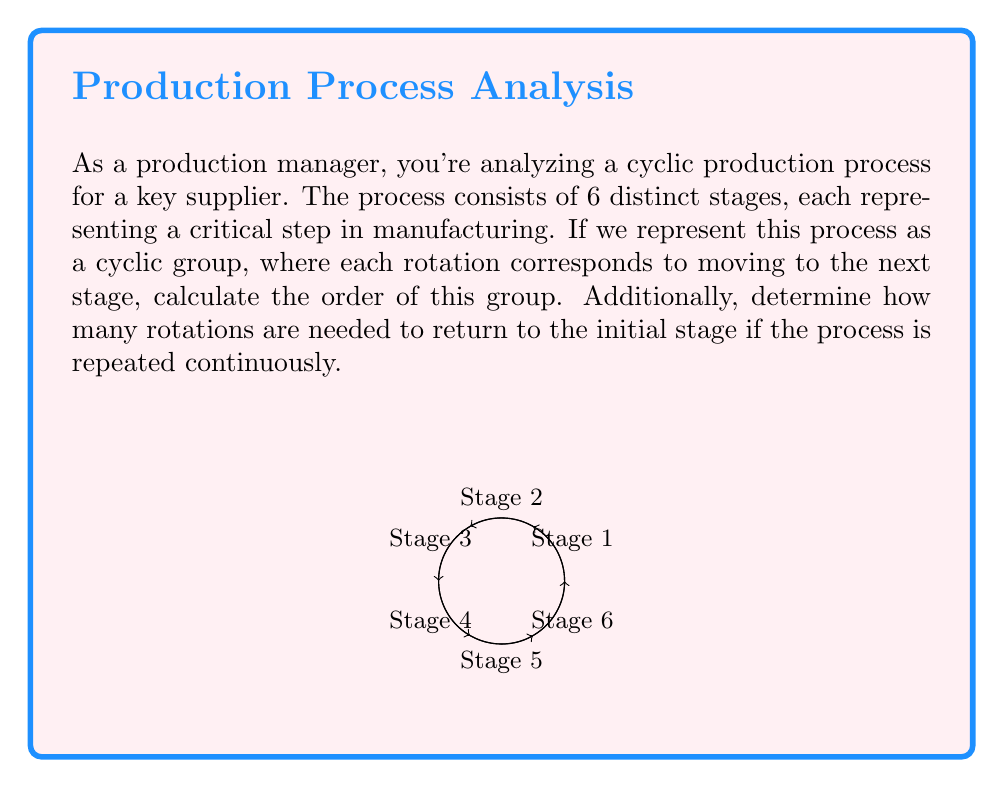Could you help me with this problem? Let's approach this step-by-step:

1) In group theory, a cyclic group is a group that can be generated by a single element. In this case, our generator is the rotation that moves the process from one stage to the next.

2) The order of a cyclic group is the smallest positive integer $n$ such that $g^n = e$, where $g$ is the generator and $e$ is the identity element.

3) In our production cycle:
   - We have 6 distinct stages.
   - Each rotation moves us to the next stage.
   - After 6 rotations, we return to the initial stage.

4) Mathematically, if we denote our generator (one rotation) as $r$, we have:
   $r^6 = e$ (identity element, or back to the initial stage)

5) This means that the smallest positive integer $n$ such that $r^n = e$ is 6.

6) Therefore, the order of this cyclic group is 6.

7) Regarding the number of rotations needed to return to the initial stage:
   - It's the same as the order of the group.
   - Each complete cycle brings us back to the initial stage.
   - So, 6 rotations are needed to return to the initial stage.

This cyclic group can be denoted as $C_6$ or $\mathbb{Z}_6$, representing a group with 6 elements under rotation.
Answer: Order of the group: 6 